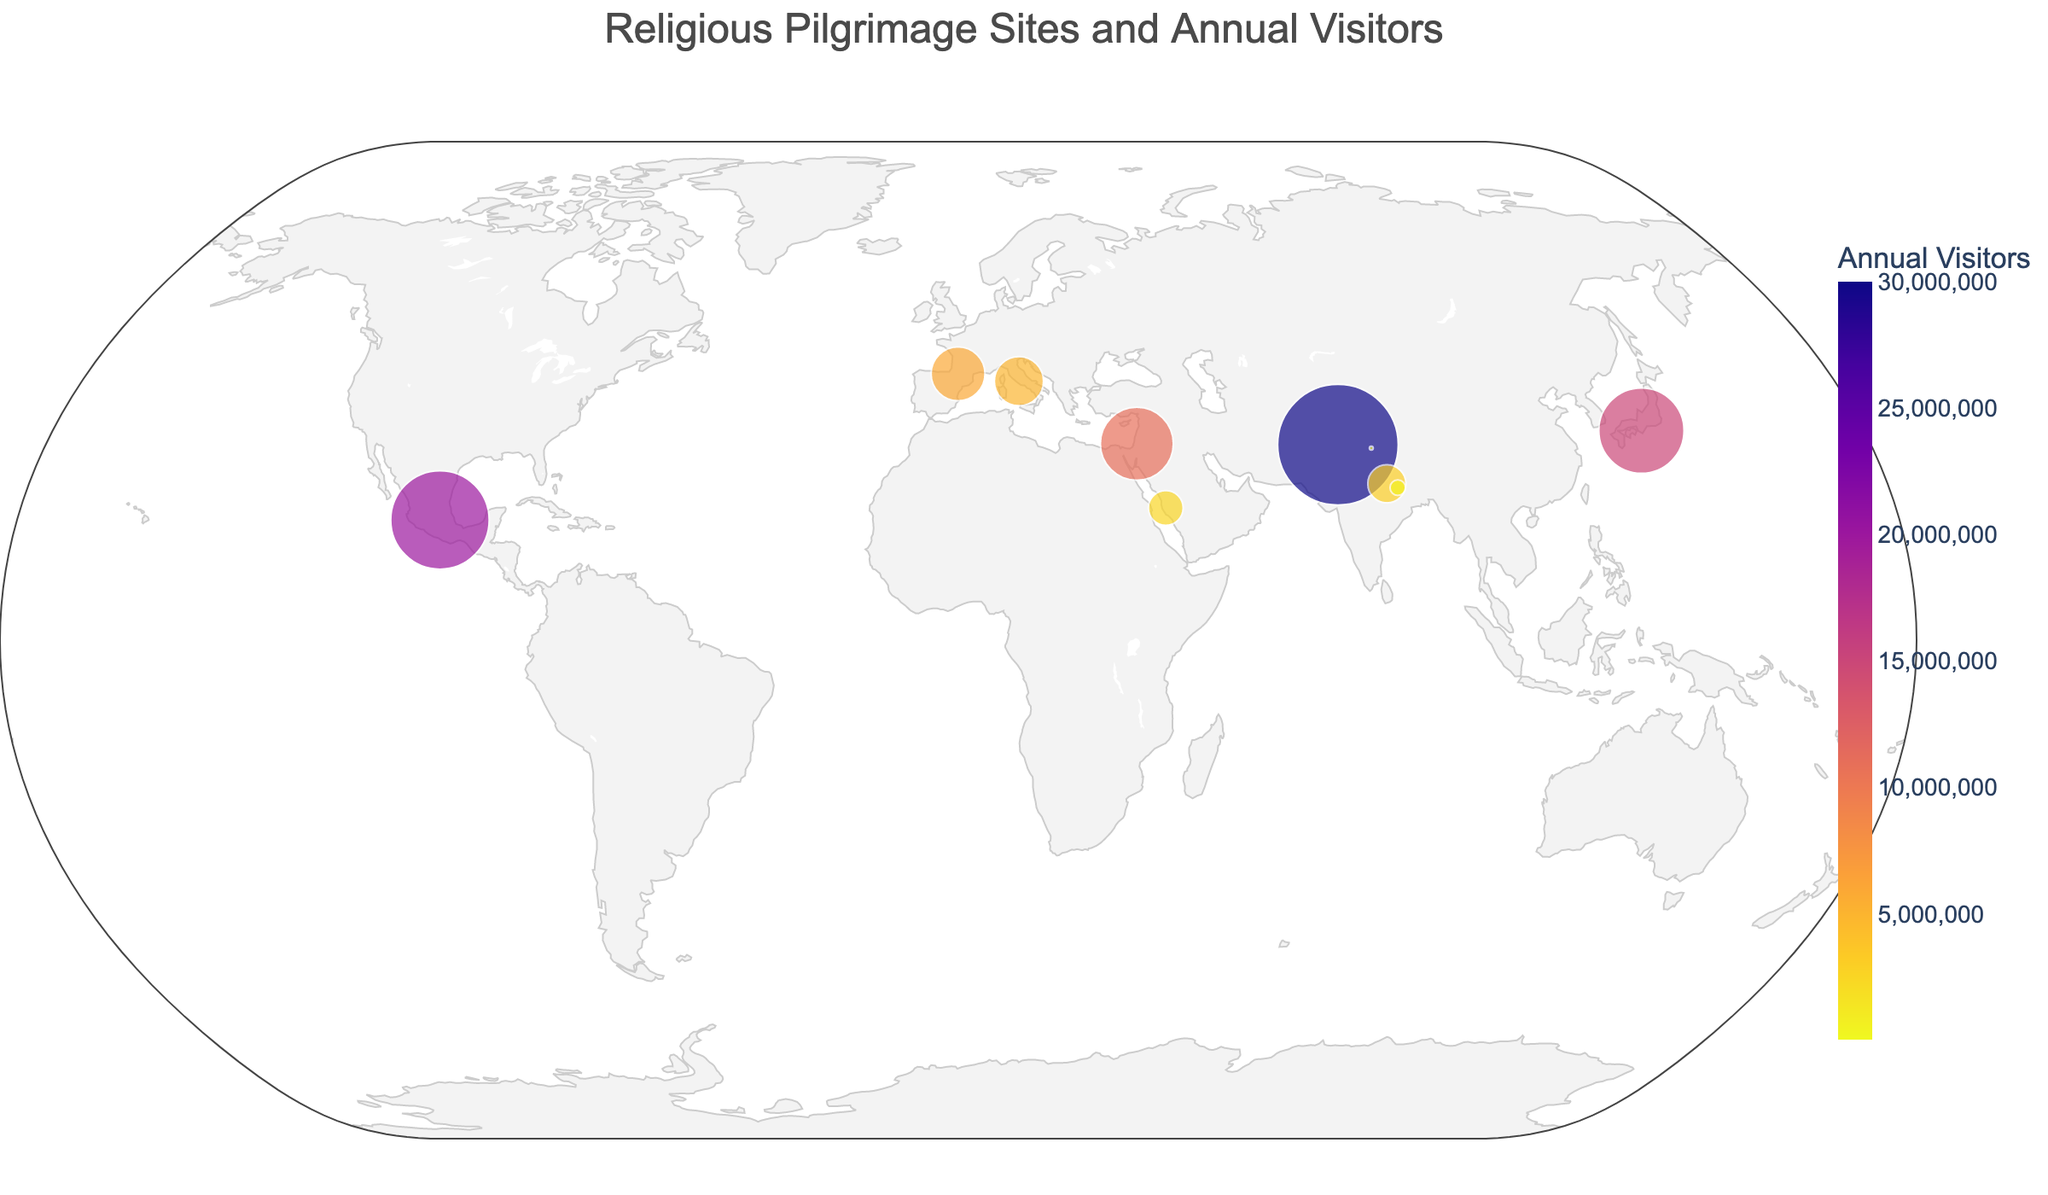What is the title of the plot? The title of the plot is located at the top center of the figure in larger font size, indicating the overall theme of the chart.
Answer: Religious Pilgrimage Sites and Annual Visitors Which site has the highest number of annual visitors? The site with the largest marker size and highest value on the color scale represents the highest number of annual visitors.
Answer: Golden Temple What is the latitude and longitude of Mecca? Mecca's geographic coordinates can be found by locating its marker on the map and referring to the hover data or annotations.
Answer: 21.4225, 39.8262 Which pilgrimage site is associated with Buddhism? By examining the hover data and annotations, we find that Bodh Gaya is the pilgrimage site associated with Buddhism.
Answer: Bodh Gaya What are the annual visitor numbers for sites associated with Christianity? Sum the annual visitors for all pilgrimage sites marked with Christianity in the hover data. The sites are Vatican City (5000000), Lourdes (6000000), and Guadalupe Basilica (20000000).
Answer: 31000000 How do the annual visitor numbers for Kashi Vishwanath compare to Western Wall? Compare the size of the markers and hover data for Kashi Vishwanath (3000000) and Western Wall (11000000). The Western Wall has more visitors.
Answer: Western Wall What is the site located at latitude 31.0672 and longitude 81.3111? Identify the marker at these coordinates and refer to its hover data or annotation, which indicates Mount Kailash.
Answer: Mount Kailash Which religious site is the closest to 25° latitude and 83° longitude? Locate the marker nearest to these coordinates, focusing on the hover data and annotations. Kashi Vishwanath is situated at latitude 25.3176 and longitude 83.0107, the closest to 25° latitude and 83° longitude.
Answer: Kashi Vishwanath Which pilgrimage site has the smallest annual visitor number? The site with the smallest marker size and lowest value on the color scale indicates the smallest number of annual visitors, which is Mount Kailash.
Answer: Mount Kailash 